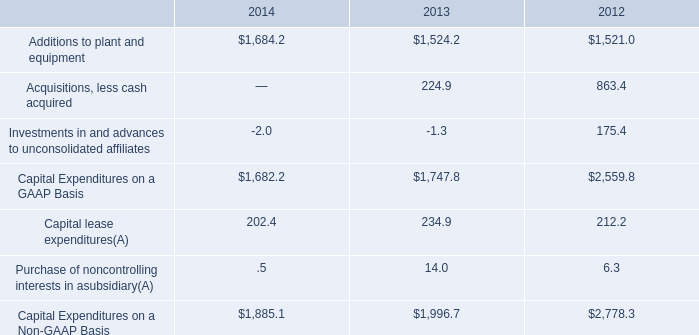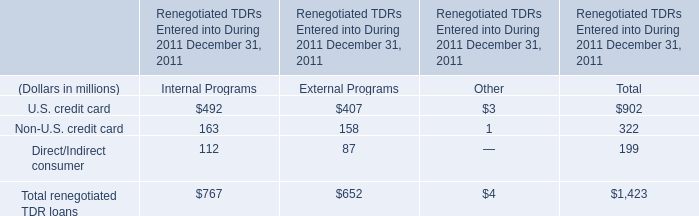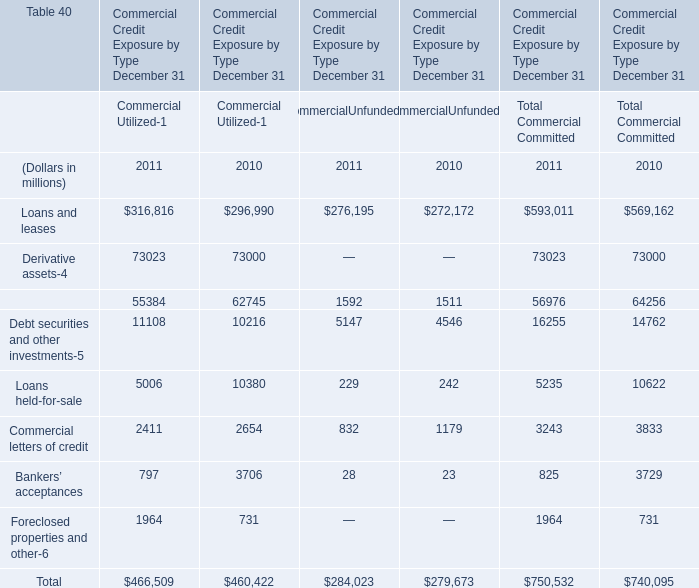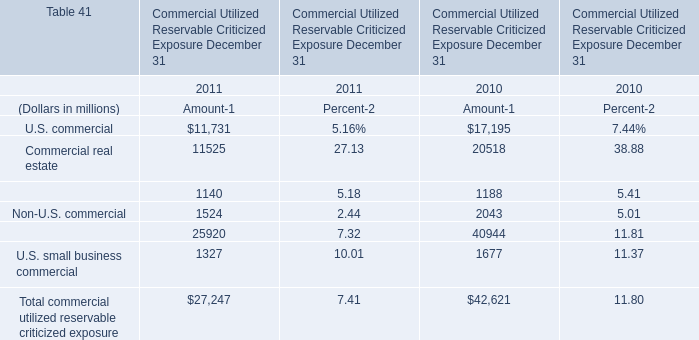In the year with lowest amount of U.S. commercial for amount , what's the amount of Commercial real estate and U.S. commercial? (in million) 
Computations: (11731 + 11525)
Answer: 23256.0. 